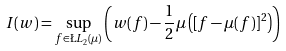<formula> <loc_0><loc_0><loc_500><loc_500>I ( w ) = \sup _ { f \in \L L _ { 2 } ( \mu ) } { \left ( w ( f ) - \frac { 1 } { 2 } \mu \left ( [ f - \mu ( f ) ] ^ { 2 } \right ) \right ) }</formula> 